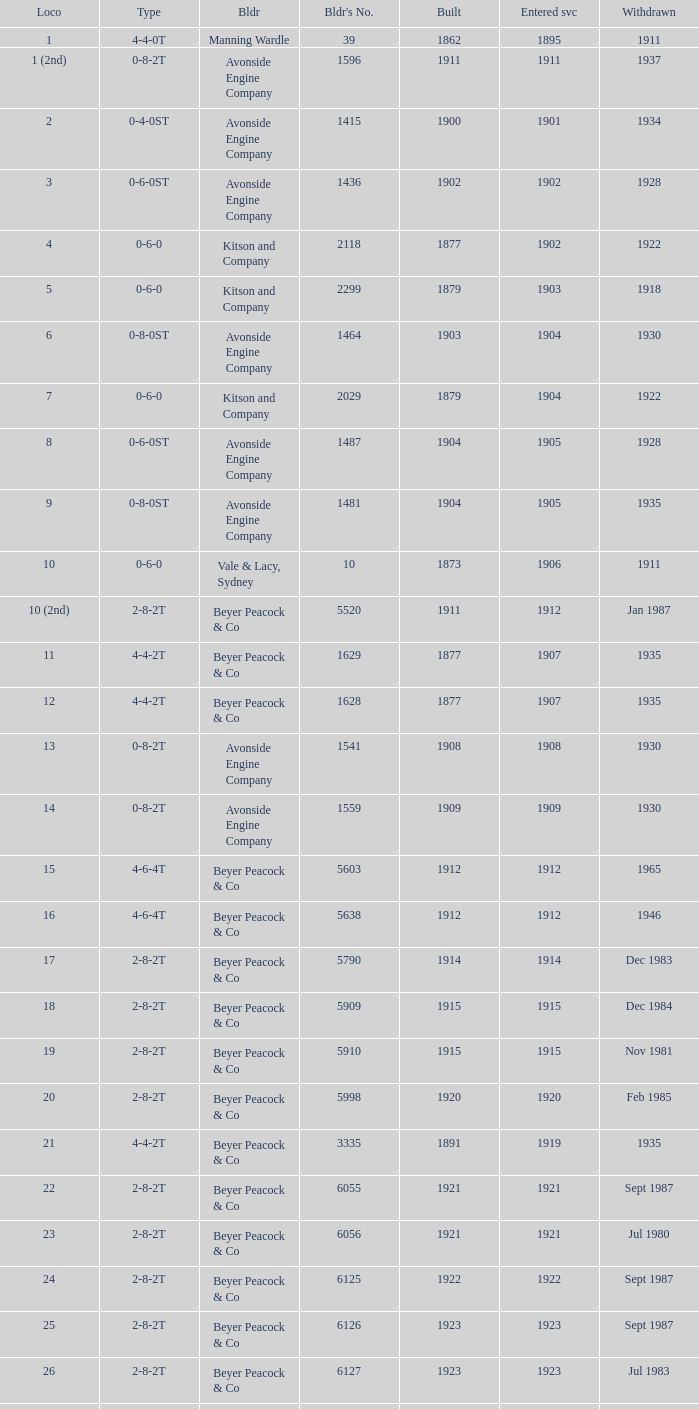How many years entered service when there were 13 locomotives? 1.0. 